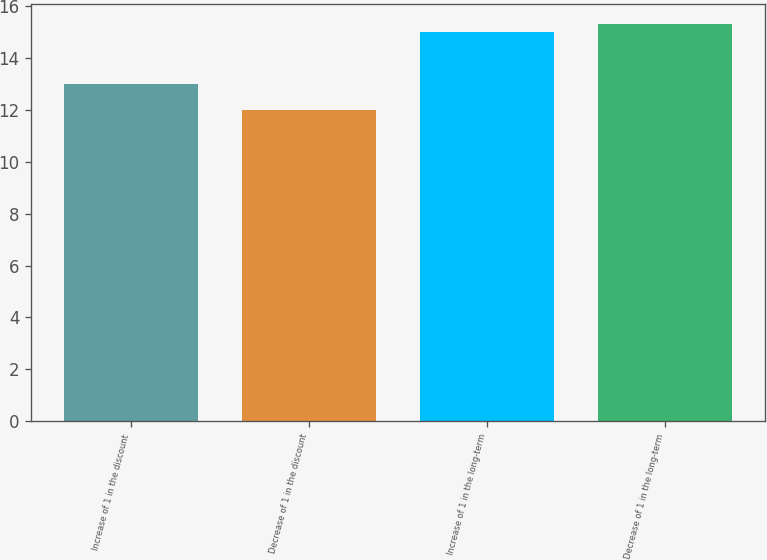Convert chart to OTSL. <chart><loc_0><loc_0><loc_500><loc_500><bar_chart><fcel>Increase of 1 in the discount<fcel>Decrease of 1 in the discount<fcel>Increase of 1 in the long-term<fcel>Decrease of 1 in the long-term<nl><fcel>13<fcel>12<fcel>15<fcel>15.3<nl></chart> 